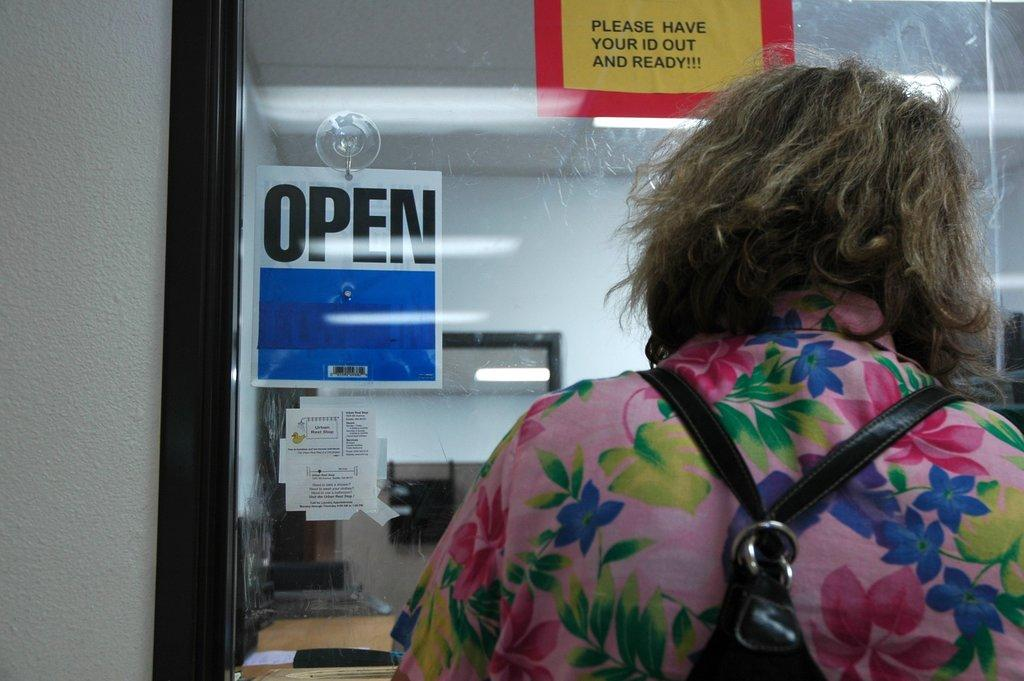What is the main subject of the image? There is a person standing in the image. What can be observed about the person's attire? The person is wearing a black bag. Which direction is the person facing? The person is facing their back. What type of building can be seen in the image? There is a building with glass windows in the image. Are there any additional decorations or features on the building? Yes, posters are attached to the building. What type of tramp can be seen jumping in the image? There is no tramp present in the image; it features a person standing with their back facing the camera. How many pages are visible on the sheet in the image? There is no sheet or pages present in the image. 